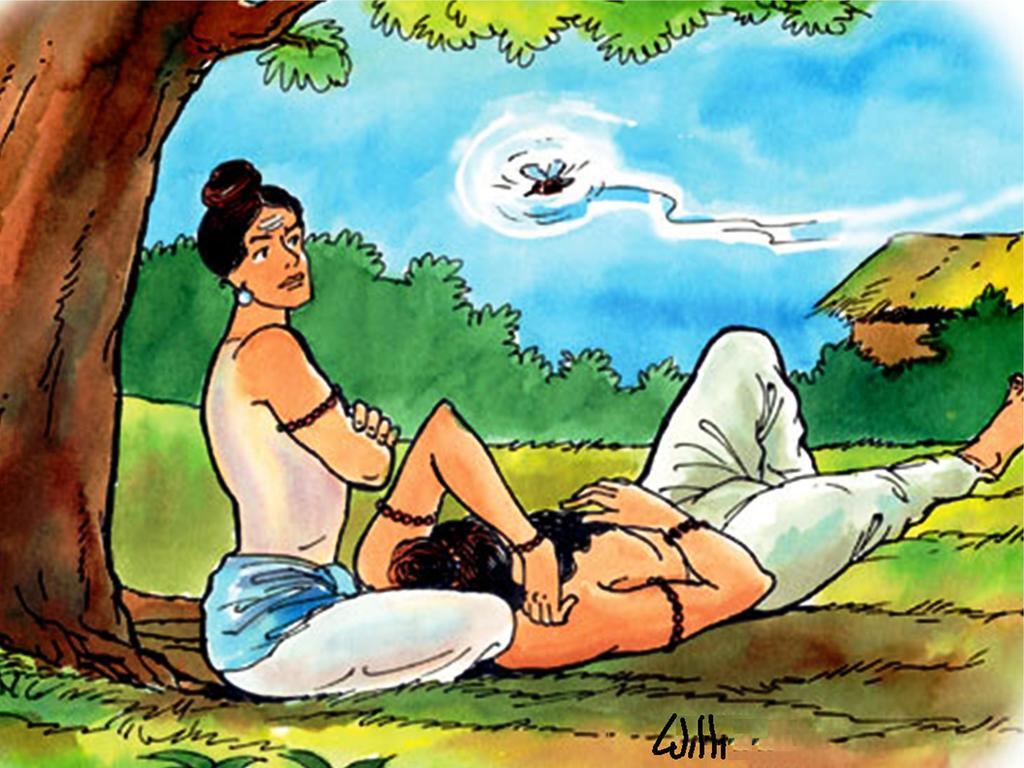How would you summarize this image in a sentence or two? In this image I can see the painting. In the painting I can see two people. To the left I can see the tree. In the background I can see the house, plants, bird and the sky. 